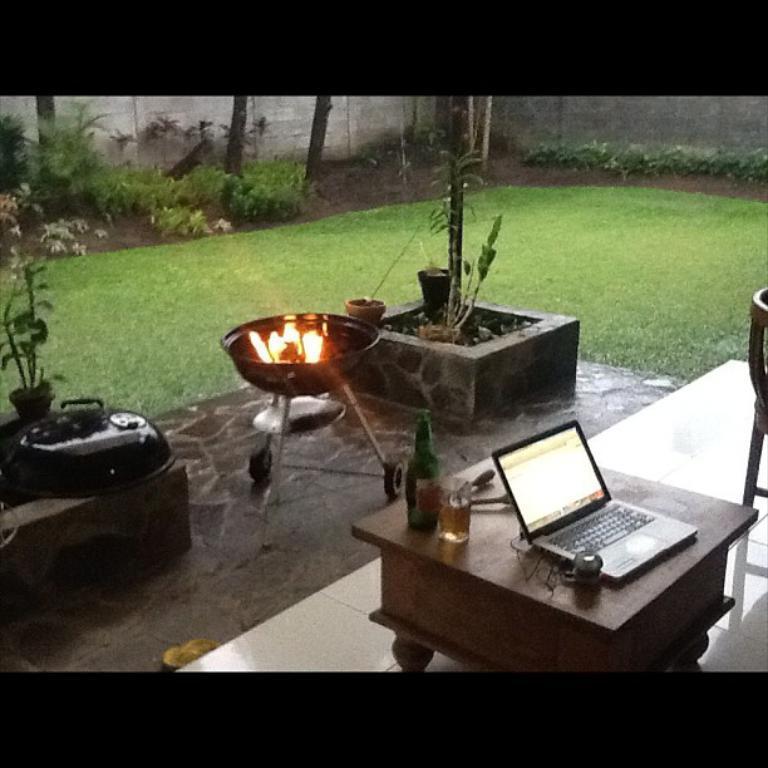Please provide a concise description of this image. In this image I can see a table. On the table there is a laptop,bottle and the glass. In front of it there is a fire bowl and flower pots. In the background there are trees and the wall. 